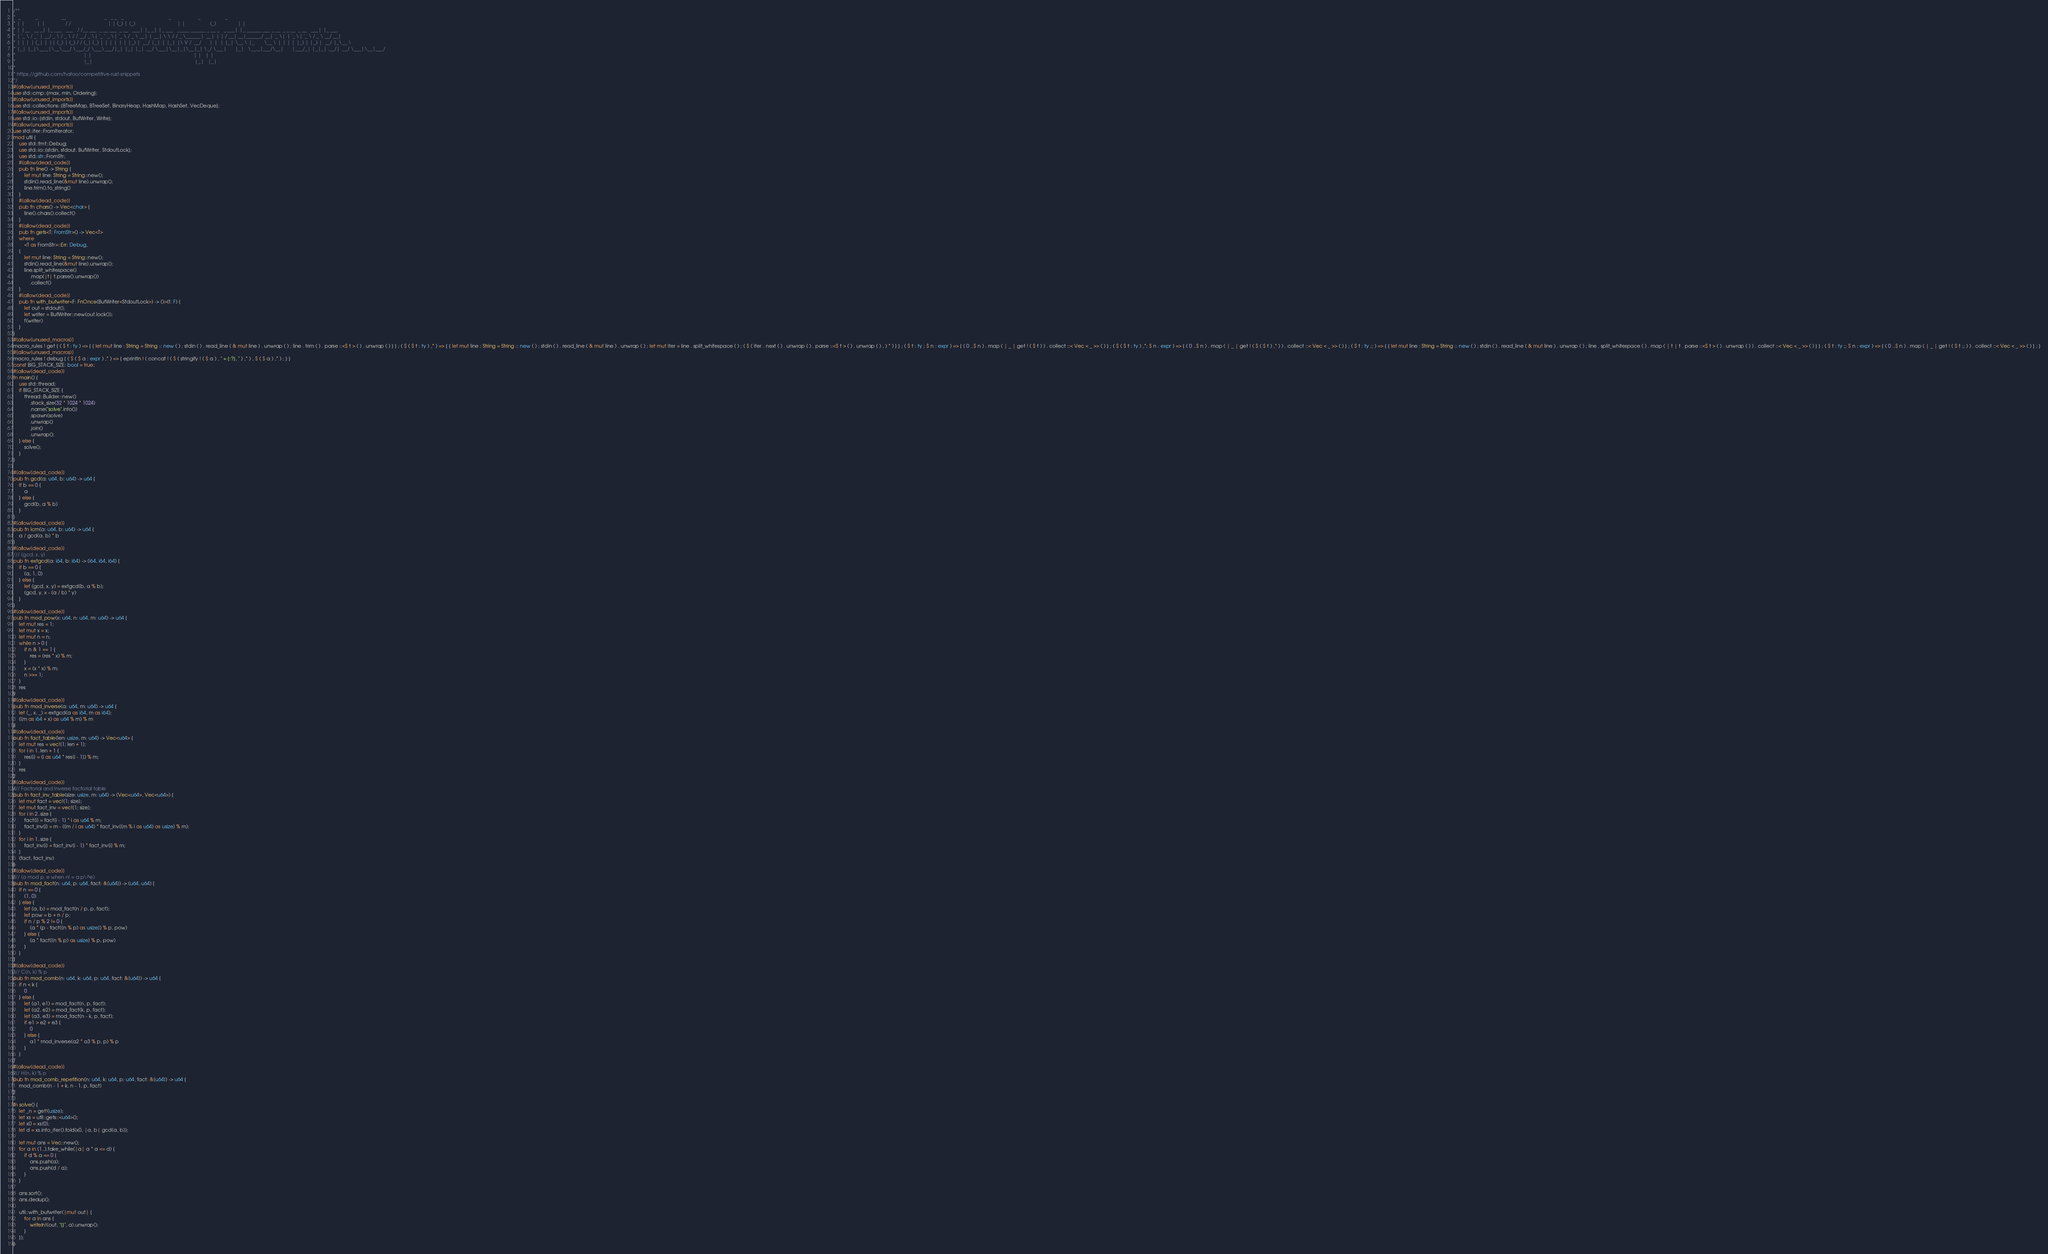Convert code to text. <code><loc_0><loc_0><loc_500><loc_500><_Rust_>/**
*  _           _                 __                            _   _ _   _                                 _                    _                  _
* | |         | |               / /                           | | (_) | (_)                               | |                  (_)                | |
* | |__   __ _| |_ ___   ___   / /__ ___  _ __ ___  _ __   ___| |_ _| |_ ___   _____ ______ _ __ _   _ ___| |_ ______ ___ _ __  _ _ __  _ __   ___| |_ ___
* | '_ \ / _` | __/ _ \ / _ \ / / __/ _ \| '_ ` _ \| '_ \ / _ \ __| | __| \ \ / / _ \______| '__| | | / __| __|______/ __| '_ \| | '_ \| '_ \ / _ \ __/ __|
* | | | | (_| | || (_) | (_) / / (_| (_) | | | | | | |_) |  __/ |_| | |_| |\ V /  __/      | |  | |_| \__ \ |_       \__ \ | | | | |_) | |_) |  __/ |_\__ \
* |_| |_|\__,_|\__\___/ \___/_/ \___\___/|_| |_| |_| .__/ \___|\__|_|\__|_| \_/ \___|      |_|   \__,_|___/\__|      |___/_| |_|_| .__/| .__/ \___|\__|___/
*                                                  | |                                                                           | |   | |
*                                                  |_|                                                                           |_|   |_|
*
* https://github.com/hatoo/competitive-rust-snippets
*/
#[allow(unused_imports)]
use std::cmp::{max, min, Ordering};
#[allow(unused_imports)]
use std::collections::{BTreeMap, BTreeSet, BinaryHeap, HashMap, HashSet, VecDeque};
#[allow(unused_imports)]
use std::io::{stdin, stdout, BufWriter, Write};
#[allow(unused_imports)]
use std::iter::FromIterator;
mod util {
    use std::fmt::Debug;
    use std::io::{stdin, stdout, BufWriter, StdoutLock};
    use std::str::FromStr;
    #[allow(dead_code)]
    pub fn line() -> String {
        let mut line: String = String::new();
        stdin().read_line(&mut line).unwrap();
        line.trim().to_string()
    }
    #[allow(dead_code)]
    pub fn chars() -> Vec<char> {
        line().chars().collect()
    }
    #[allow(dead_code)]
    pub fn gets<T: FromStr>() -> Vec<T>
    where
        <T as FromStr>::Err: Debug,
    {
        let mut line: String = String::new();
        stdin().read_line(&mut line).unwrap();
        line.split_whitespace()
            .map(|t| t.parse().unwrap())
            .collect()
    }
    #[allow(dead_code)]
    pub fn with_bufwriter<F: FnOnce(BufWriter<StdoutLock>) -> ()>(f: F) {
        let out = stdout();
        let writer = BufWriter::new(out.lock());
        f(writer)
    }
}
#[allow(unused_macros)]
macro_rules ! get { ( $ t : ty ) => { { let mut line : String = String :: new ( ) ; stdin ( ) . read_line ( & mut line ) . unwrap ( ) ; line . trim ( ) . parse ::<$ t > ( ) . unwrap ( ) } } ; ( $ ( $ t : ty ) ,* ) => { { let mut line : String = String :: new ( ) ; stdin ( ) . read_line ( & mut line ) . unwrap ( ) ; let mut iter = line . split_whitespace ( ) ; ( $ ( iter . next ( ) . unwrap ( ) . parse ::<$ t > ( ) . unwrap ( ) , ) * ) } } ; ( $ t : ty ; $ n : expr ) => { ( 0 ..$ n ) . map ( | _ | get ! ( $ t ) ) . collect ::< Vec < _ >> ( ) } ; ( $ ( $ t : ty ) ,*; $ n : expr ) => { ( 0 ..$ n ) . map ( | _ | get ! ( $ ( $ t ) ,* ) ) . collect ::< Vec < _ >> ( ) } ; ( $ t : ty ;; ) => { { let mut line : String = String :: new ( ) ; stdin ( ) . read_line ( & mut line ) . unwrap ( ) ; line . split_whitespace ( ) . map ( | t | t . parse ::<$ t > ( ) . unwrap ( ) ) . collect ::< Vec < _ >> ( ) } } ; ( $ t : ty ;; $ n : expr ) => { ( 0 ..$ n ) . map ( | _ | get ! ( $ t ;; ) ) . collect ::< Vec < _ >> ( ) } ; }
#[allow(unused_macros)]
macro_rules ! debug { ( $ ( $ a : expr ) ,* ) => { eprintln ! ( concat ! ( $ ( stringify ! ( $ a ) , " = {:?}, " ) ,* ) , $ ( $ a ) ,* ) ; } }
const BIG_STACK_SIZE: bool = true;
#[allow(dead_code)]
fn main() {
    use std::thread;
    if BIG_STACK_SIZE {
        thread::Builder::new()
            .stack_size(32 * 1024 * 1024)
            .name("solve".into())
            .spawn(solve)
            .unwrap()
            .join()
            .unwrap();
    } else {
        solve();
    }
}

#[allow(dead_code)]
pub fn gcd(a: u64, b: u64) -> u64 {
    if b == 0 {
        a
    } else {
        gcd(b, a % b)
    }
}
#[allow(dead_code)]
pub fn lcm(a: u64, b: u64) -> u64 {
    a / gcd(a, b) * b
}
#[allow(dead_code)]
/// (gcd, x, y)
pub fn extgcd(a: i64, b: i64) -> (i64, i64, i64) {
    if b == 0 {
        (a, 1, 0)
    } else {
        let (gcd, x, y) = extgcd(b, a % b);
        (gcd, y, x - (a / b) * y)
    }
}
#[allow(dead_code)]
pub fn mod_pow(x: u64, n: u64, m: u64) -> u64 {
    let mut res = 1;
    let mut x = x;
    let mut n = n;
    while n > 0 {
        if n & 1 == 1 {
            res = (res * x) % m;
        }
        x = (x * x) % m;
        n >>= 1;
    }
    res
}
#[allow(dead_code)]
pub fn mod_inverse(a: u64, m: u64) -> u64 {
    let (_, x, _) = extgcd(a as i64, m as i64);
    ((m as i64 + x) as u64 % m) % m
}
#[allow(dead_code)]
pub fn fact_table(len: usize, m: u64) -> Vec<u64> {
    let mut res = vec![1; len + 1];
    for i in 1..len + 1 {
        res[i] = (i as u64 * res[i - 1]) % m;
    }
    res
}
#[allow(dead_code)]
/// Factorial and Inverse factorial table
pub fn fact_inv_table(size: usize, m: u64) -> (Vec<u64>, Vec<u64>) {
    let mut fact = vec![1; size];
    let mut fact_inv = vec![1; size];
    for i in 2..size {
        fact[i] = fact[i - 1] * i as u64 % m;
        fact_inv[i] = m - ((m / i as u64) * fact_inv[(m % i as u64) as usize] % m);
    }
    for i in 1..size {
        fact_inv[i] = fact_inv[i - 1] * fact_inv[i] % m;
    }
    (fact, fact_inv)
}
#[allow(dead_code)]
/// (a mod p, e when n! = a p\^e)
pub fn mod_fact(n: u64, p: u64, fact: &[u64]) -> (u64, u64) {
    if n == 0 {
        (1, 0)
    } else {
        let (a, b) = mod_fact(n / p, p, fact);
        let pow = b + n / p;
        if n / p % 2 != 0 {
            (a * (p - fact[(n % p) as usize]) % p, pow)
        } else {
            (a * fact[(n % p) as usize] % p, pow)
        }
    }
}
#[allow(dead_code)]
/// C(n, k) % p
pub fn mod_comb(n: u64, k: u64, p: u64, fact: &[u64]) -> u64 {
    if n < k {
        0
    } else {
        let (a1, e1) = mod_fact(n, p, fact);
        let (a2, e2) = mod_fact(k, p, fact);
        let (a3, e3) = mod_fact(n - k, p, fact);
        if e1 > e2 + e3 {
            0
        } else {
            a1 * mod_inverse(a2 * a3 % p, p) % p
        }
    }
}
#[allow(dead_code)]
/// H(n, k) % p
pub fn mod_comb_repetition(n: u64, k: u64, p: u64, fact: &[u64]) -> u64 {
    mod_comb(n - 1 + k, n - 1, p, fact)
}

fn solve() {
    let _n = get!(usize);
    let xs = util::gets::<u64>();
    let x0 = xs[0];
    let d = xs.into_iter().fold(x0, |a, b| gcd(a, b));

    let mut ans = Vec::new();
    for a in (1..).take_while(|a| a * a <= d) {
        if d % a == 0 {
            ans.push(a);
            ans.push(d / a);
        }
    }

    ans.sort();
    ans.dedup();

    util::with_bufwriter(|mut out| {
        for a in ans {
            writeln!(out, "{}", a).unwrap();
        }
    });
}

</code> 